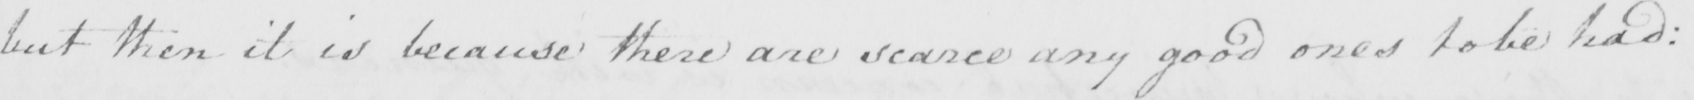Transcribe the text shown in this historical manuscript line. but then it is because there are scarce any good ones to be had : 